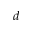Convert formula to latex. <formula><loc_0><loc_0><loc_500><loc_500>d</formula> 